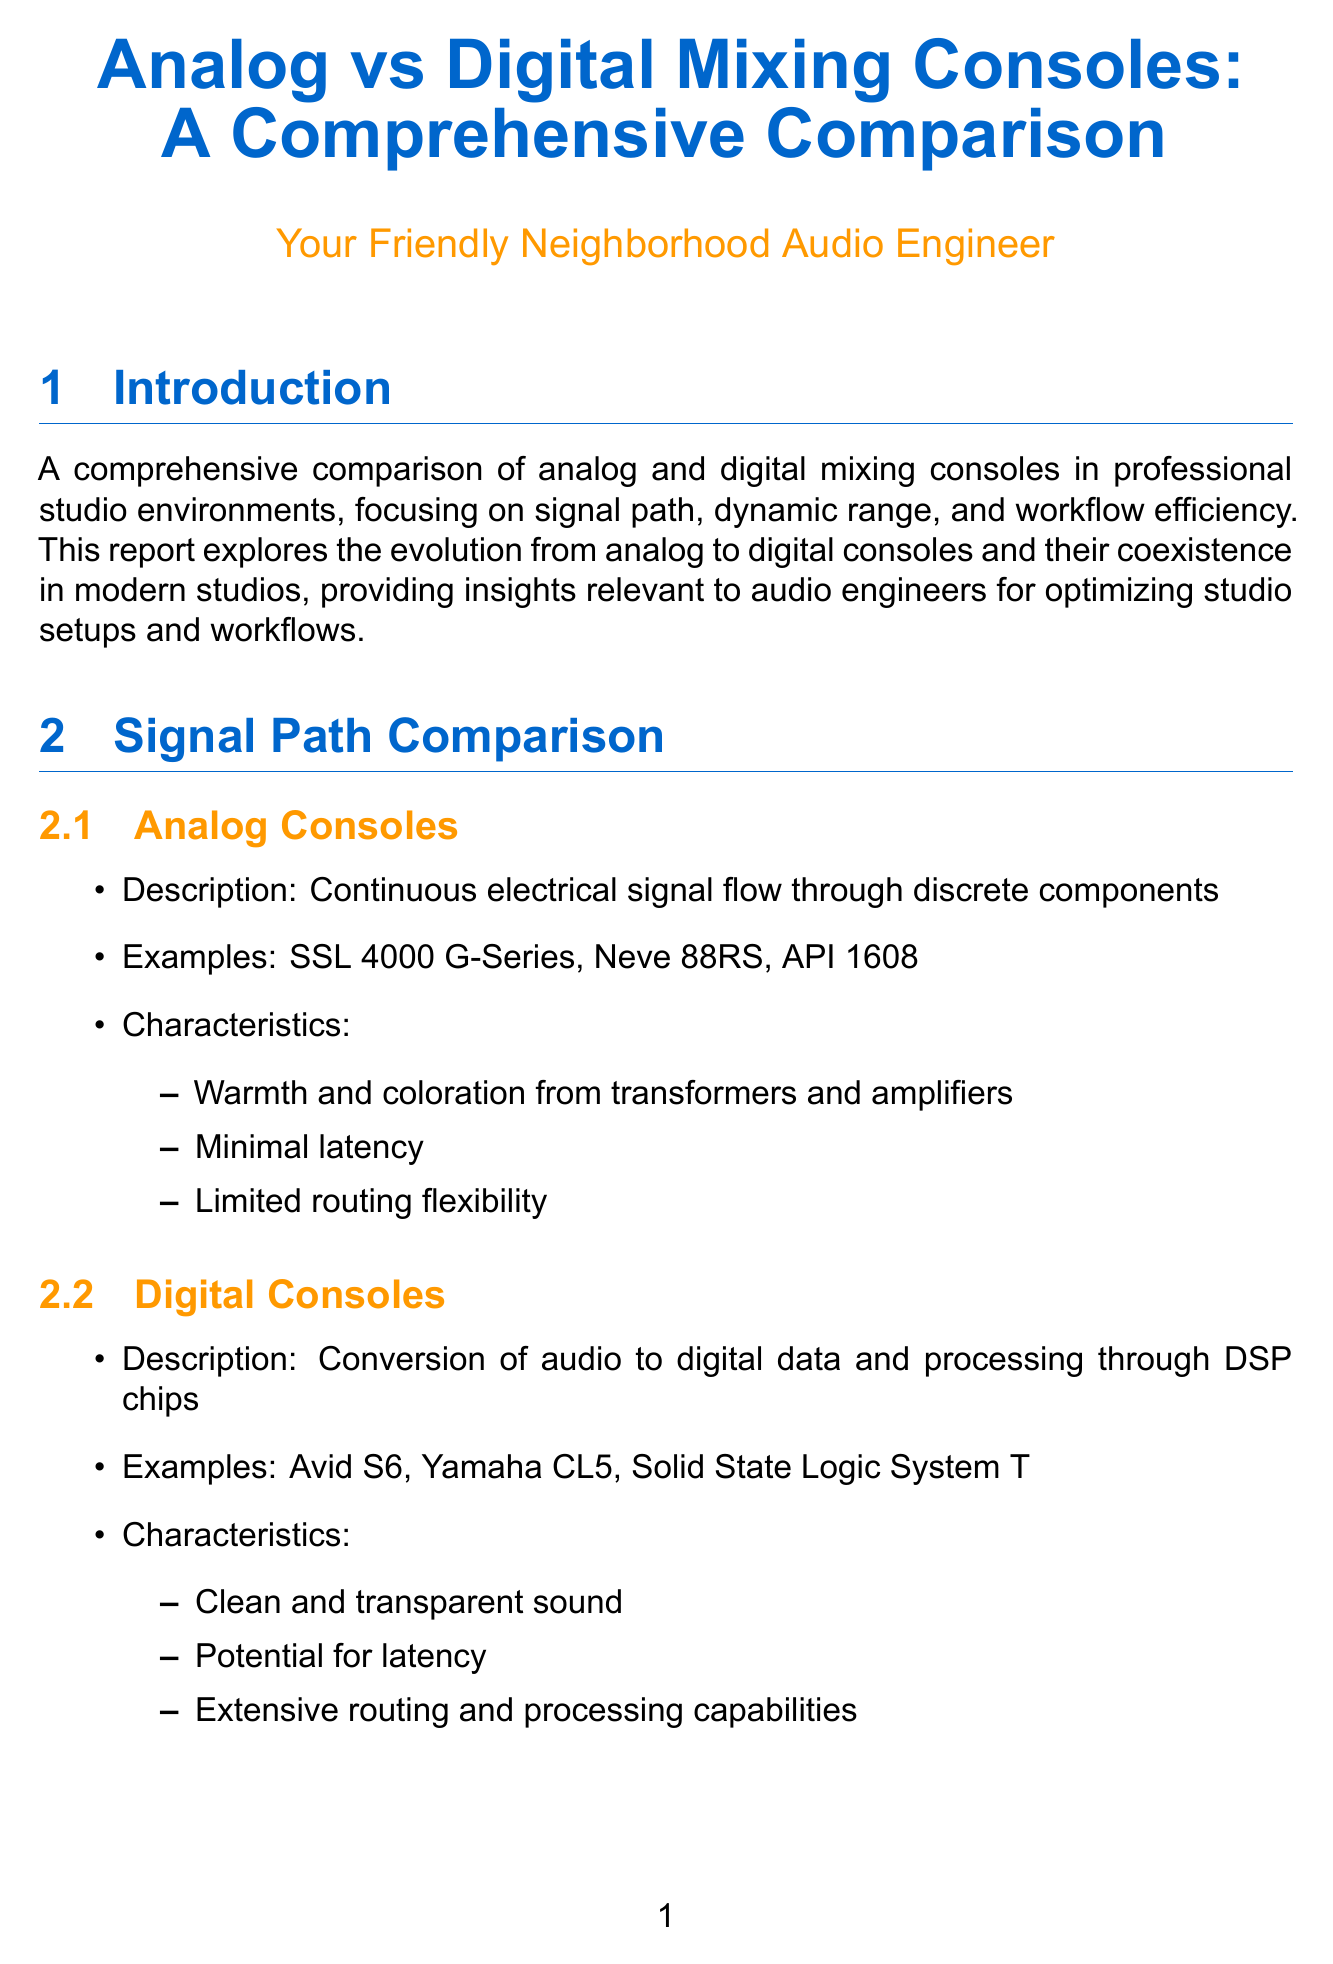what is the typical dynamic range for analog consoles? The typical dynamic range for analog consoles is stated in the document, which is between 115 to 125 dB.
Answer: 115-125 dB what is a notable performer for digital consoles? The document provides an example of a notable performer in the digital console category, which is the Stagetec Aurus.
Answer: Stagetec Aurus what is a strength of analog consoles in terms of workflow efficiency? The document lists several strengths of analog consoles, one of which is tactile control.
Answer: Tactile control how does the signal path differ between analog and digital consoles? The document describes that analog consoles use continuous electrical signal flow, while digital consoles convert audio to digital data.
Answer: Continuous electrical signal flow vs. conversion to digital data what is a benefit of using Studio A's setup? The benefits of Studio A's setup include analog warmth with digital recall.
Answer: Analog warmth with digital recall what emerging technology is mentioned in the future trends section? The document lists AI-assisted mixing as one of the emerging technologies.
Answer: AI-assisted mixing what is a weakness of digital consoles? The document states that a weakness of digital consoles is the learning curve for complex systems.
Answer: Learning curve for complex systems what is a characteristic of digital consoles? The document notes that digital consoles have extensive routing and processing capabilities as a characteristic.
Answer: Extensive routing and processing capabilities 